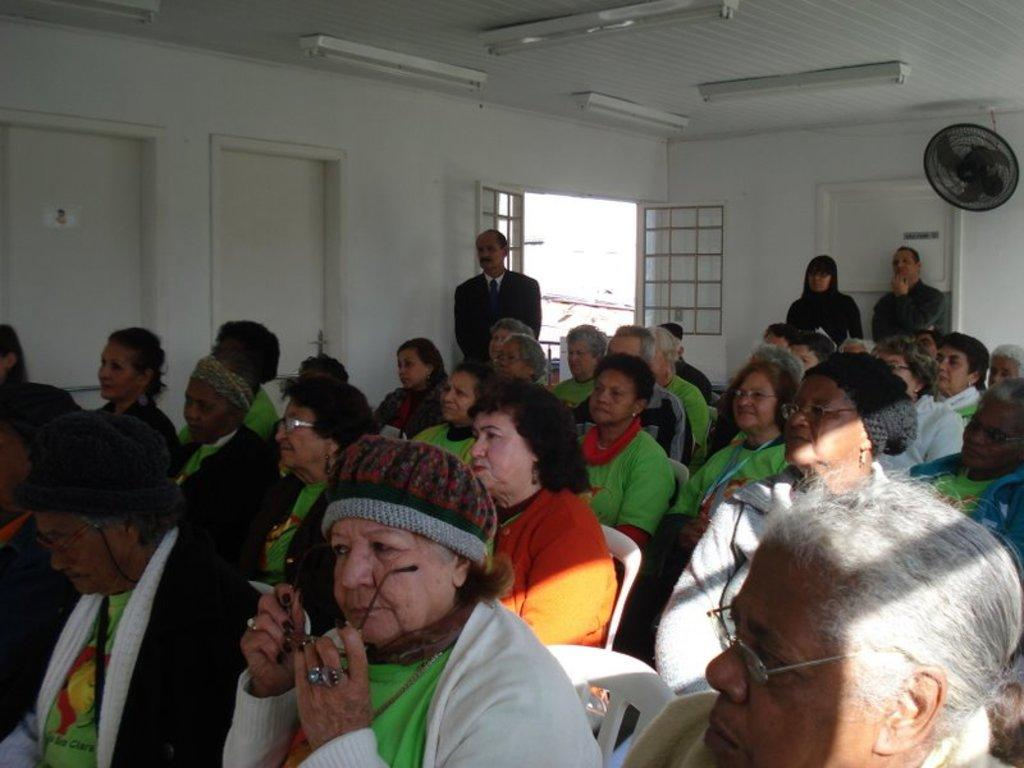What are the people in the image doing? There are many people sitting on chairs in the image. Can you describe the people in the background? In the background, there are three people standing. What is one feature of the room visible in the image? There is a door visible in the image. What is present on the ceiling in the image? There are lights on the ceiling. What device is present in the image to provide air circulation? There is a fan in the image. What position does the war take in the image? There is no war present in the image; it is a scene of people sitting and standing in a room. 